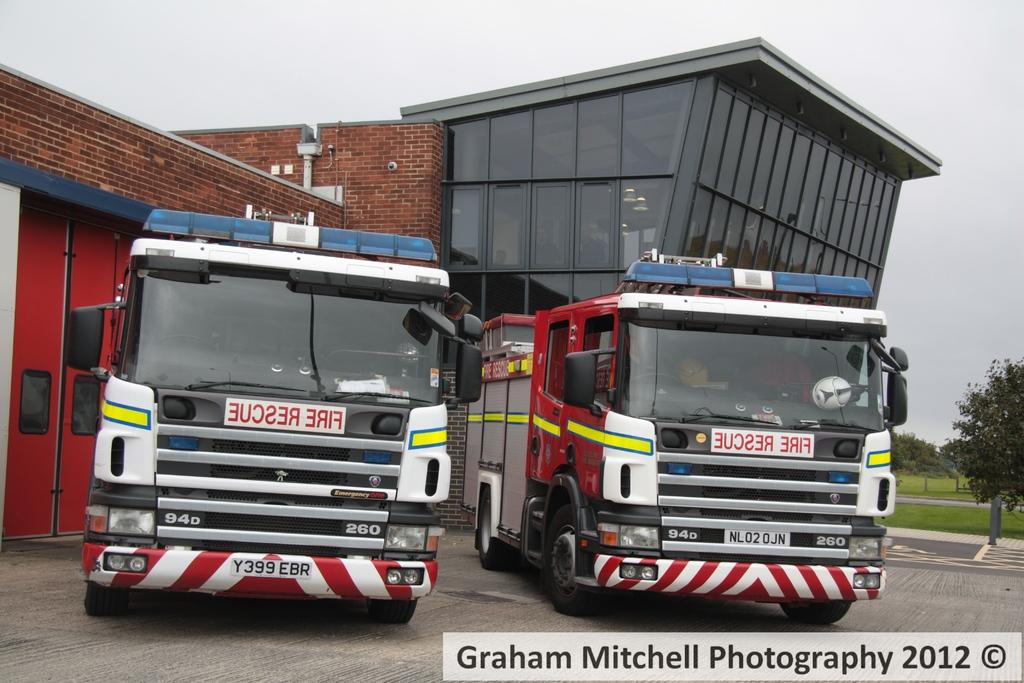What type of vehicles can be seen on the road in the image? There are two fire vehicles on the road in the image. What structure is present in the image? There is a building in the image. What type of vegetation is on the right side of the image? There are trees on the grassland on the right side of the image. What is visible above the grassland? The sky is visible above the grassland. Can you tell me which nerve is causing the firefighter's knee pain in the image? There is no indication of any firefighter or knee pain in the image; it only shows two fire vehicles on the road. What type of toy is being used by the firefighters in the image? There is no toy present in the image; it only shows two fire vehicles on the road. 